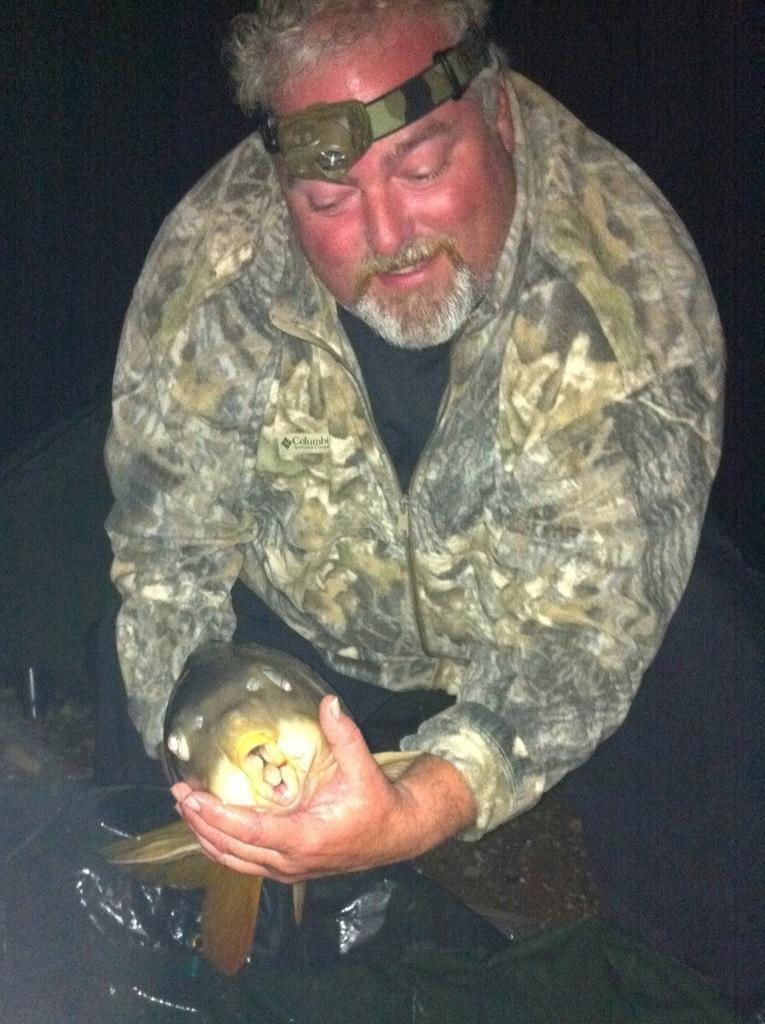Describe this image in one or two sentences. As we can see in the image there is a man wearing wearing jacket and sitting. The image is little dark. 